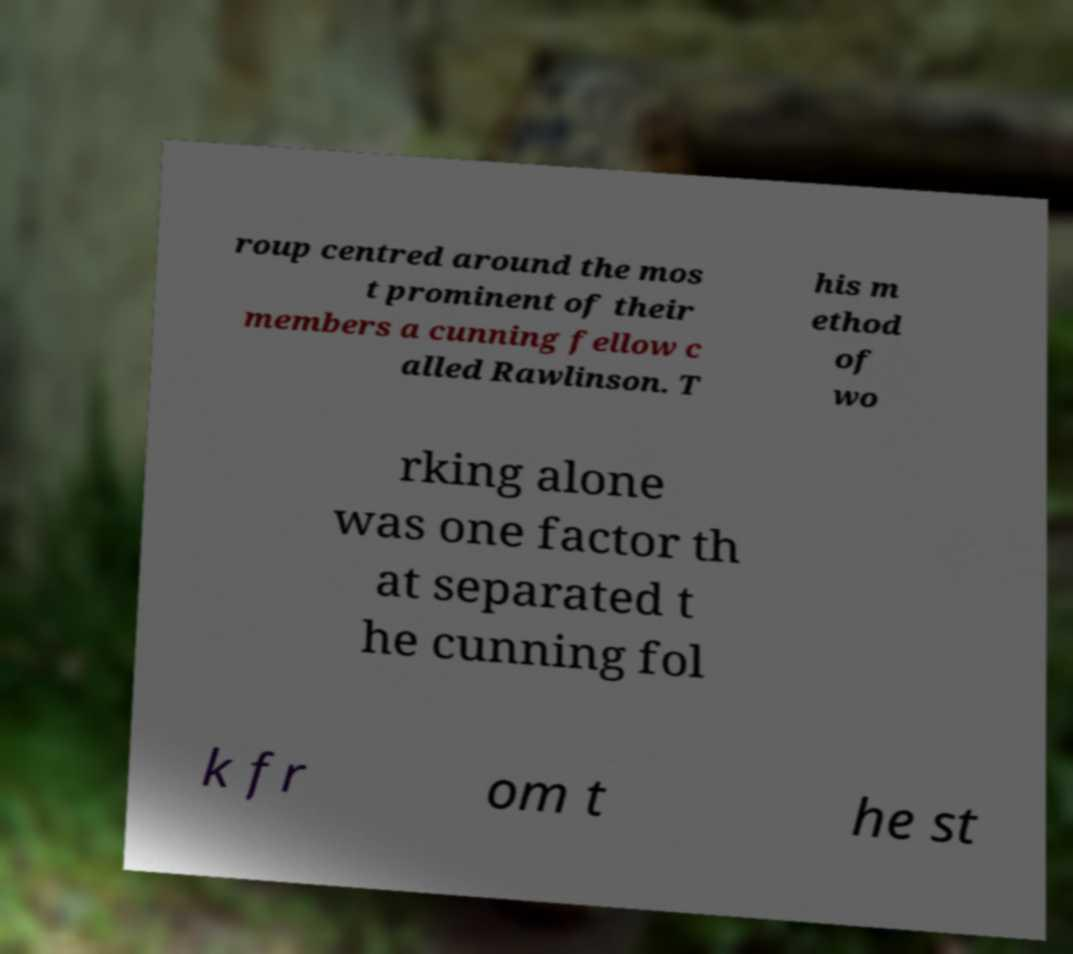Could you assist in decoding the text presented in this image and type it out clearly? roup centred around the mos t prominent of their members a cunning fellow c alled Rawlinson. T his m ethod of wo rking alone was one factor th at separated t he cunning fol k fr om t he st 